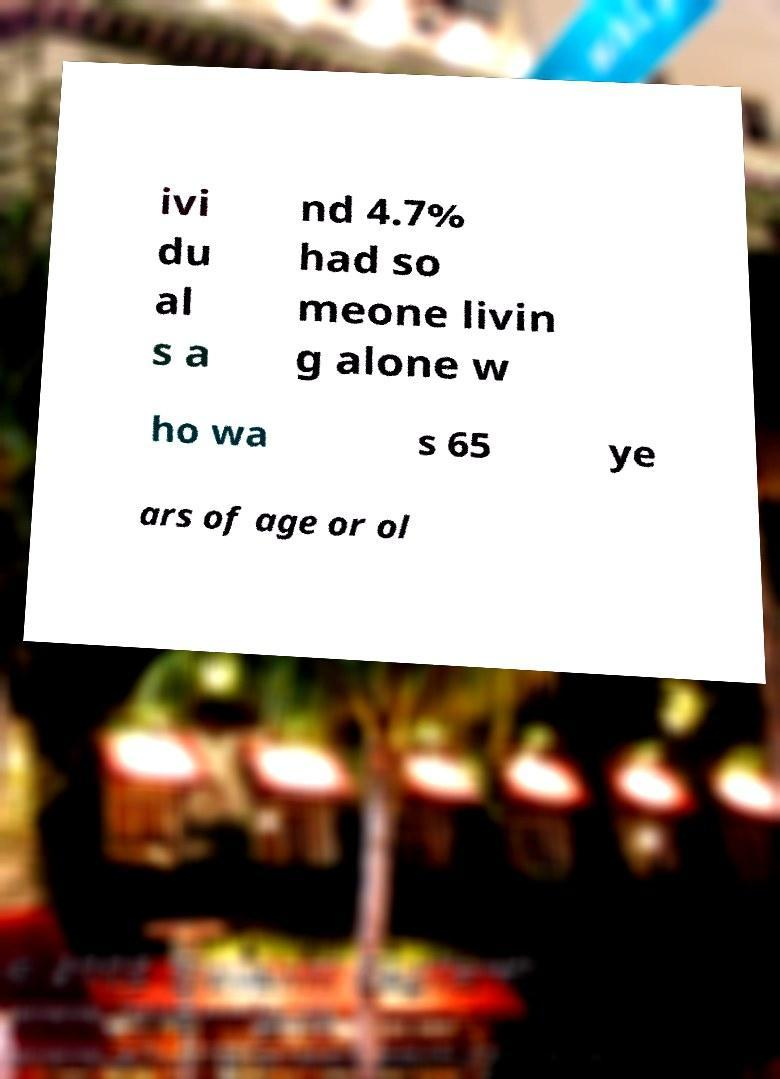Can you read and provide the text displayed in the image?This photo seems to have some interesting text. Can you extract and type it out for me? ivi du al s a nd 4.7% had so meone livin g alone w ho wa s 65 ye ars of age or ol 